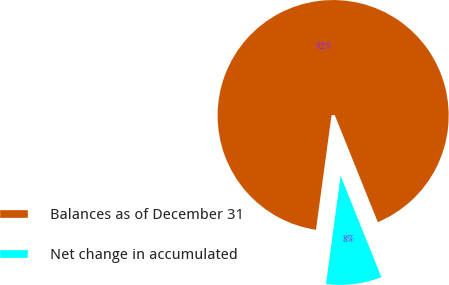Convert chart. <chart><loc_0><loc_0><loc_500><loc_500><pie_chart><fcel>Balances as of December 31<fcel>Net change in accumulated<nl><fcel>91.77%<fcel>8.23%<nl></chart> 